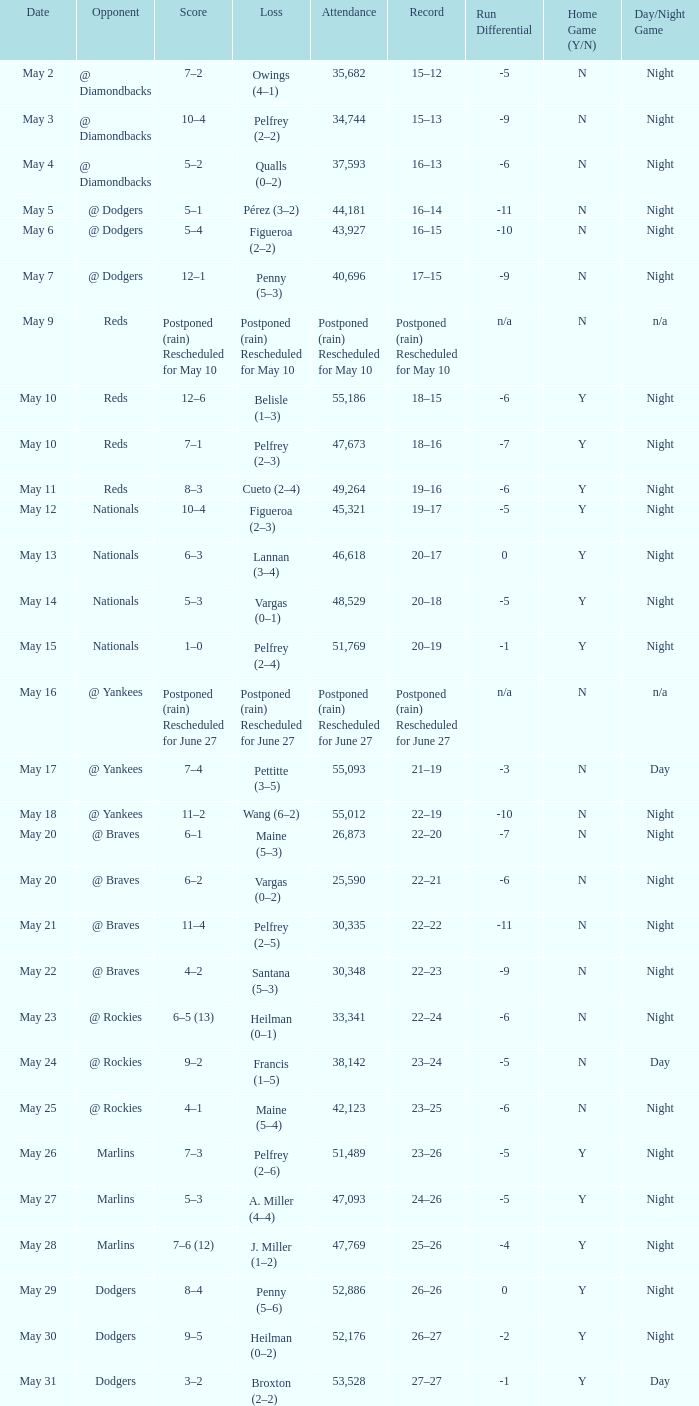Loss of postponed (rain) rescheduled for may 10 had what record? Postponed (rain) Rescheduled for May 10. 